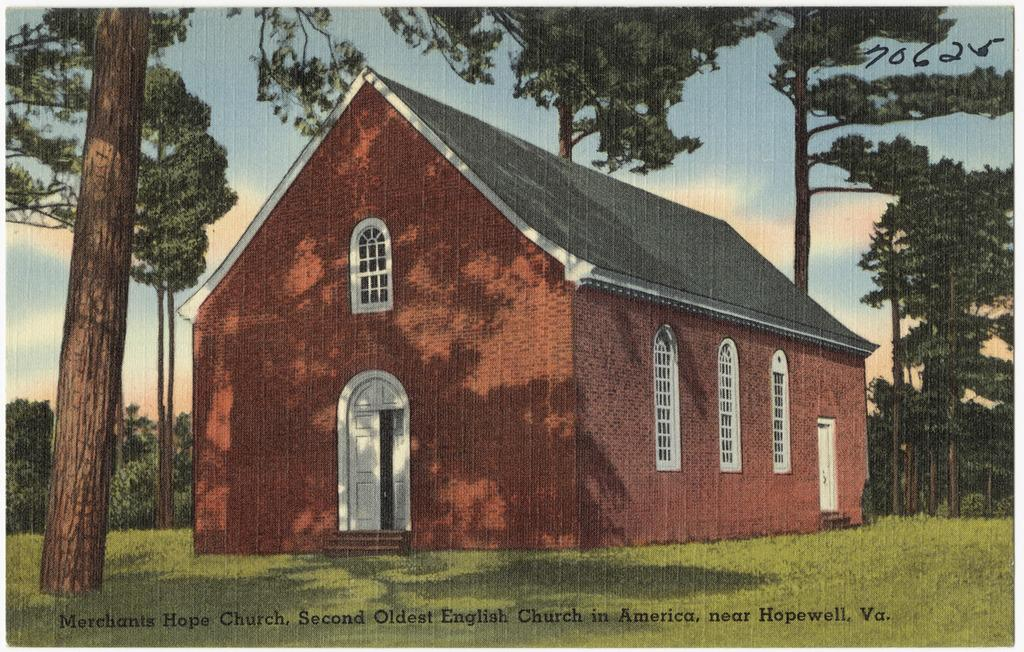What is depicted in the painting in the image? There is a painting of a house in the image. What type of vegetation can be seen in the image? There is grass and trees in the image. What is visible in the background of the image? The sky with clouds is visible in the background of the image. What additional information is provided at the bottom of the image? There is edited text at the bottom of the image. How many pests can be seen crawling on the grass in the image? There are no pests visible in the image; it features a painting of a house, grass, trees, and the sky with clouds. What type of bird is standing near the trees in the image? There are no birds, including turkeys, present in the image. 